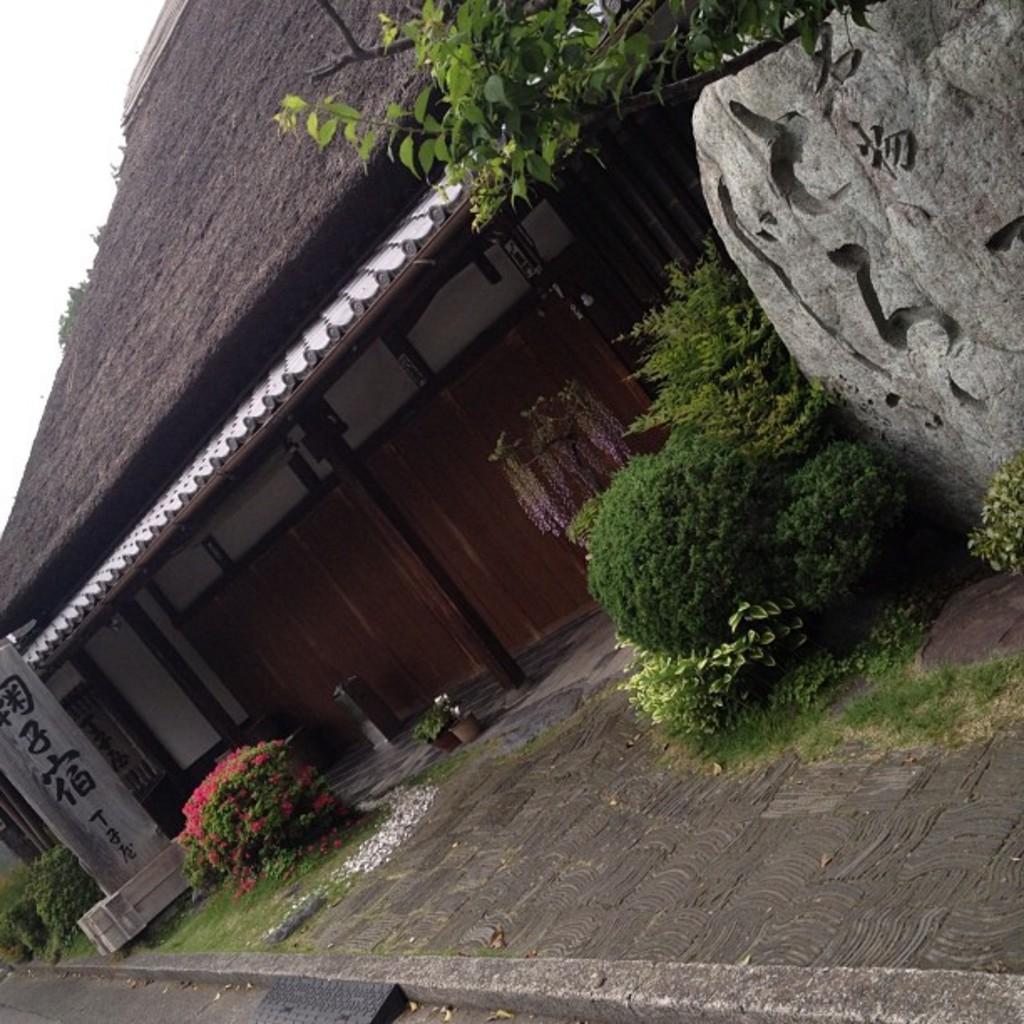How would you summarize this image in a sentence or two? In this image we can see a building, rocks, laid stone, house plants, bushes and sky in the background. 